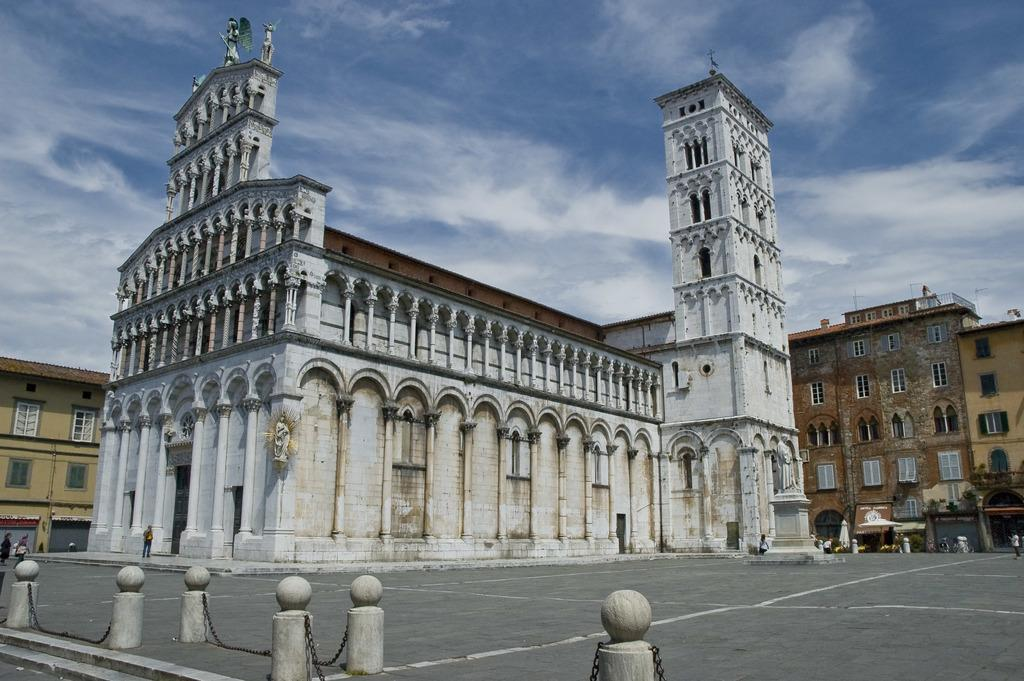What type of structures can be seen in the image? There are buildings in the image. Who or what else is present in the image? There are persons and tents in the image. What architectural features are visible at the bottom of the image? Chains and pillars are present at the bottom of the image. What can be seen in the background of the image? The sky and clouds are visible in the background of the image. What is the condition of the marble in the image? There is no marble present in the image. Can you tell me how many zebras are visible in the image? There are no zebras present in the image. 